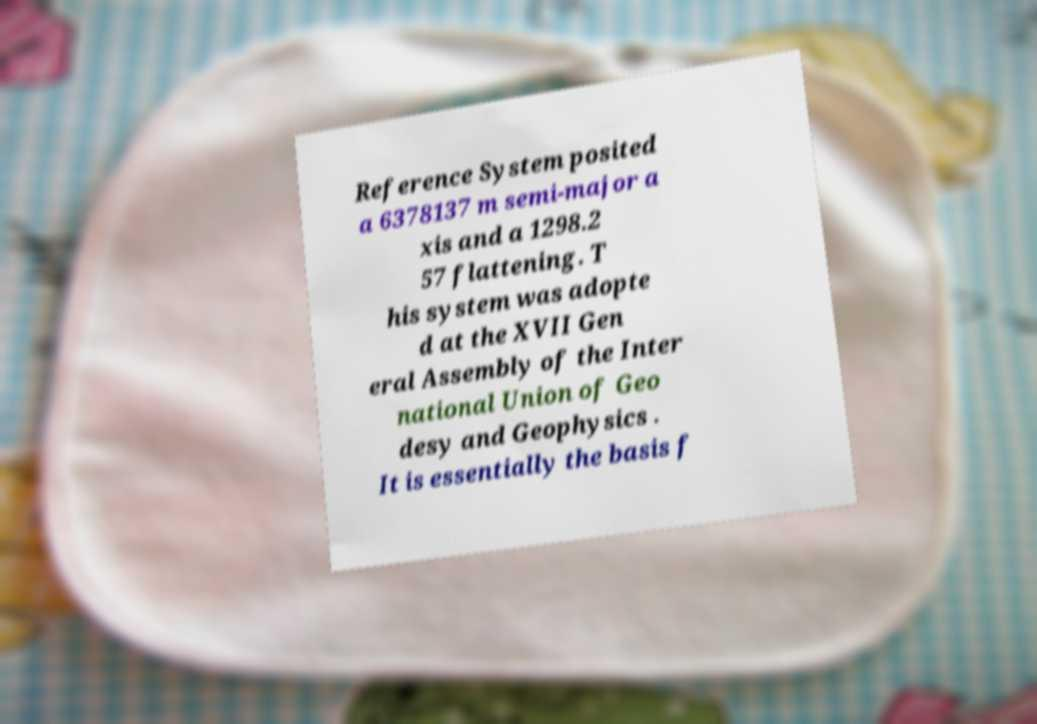Could you extract and type out the text from this image? Reference System posited a 6378137 m semi-major a xis and a 1298.2 57 flattening. T his system was adopte d at the XVII Gen eral Assembly of the Inter national Union of Geo desy and Geophysics . It is essentially the basis f 